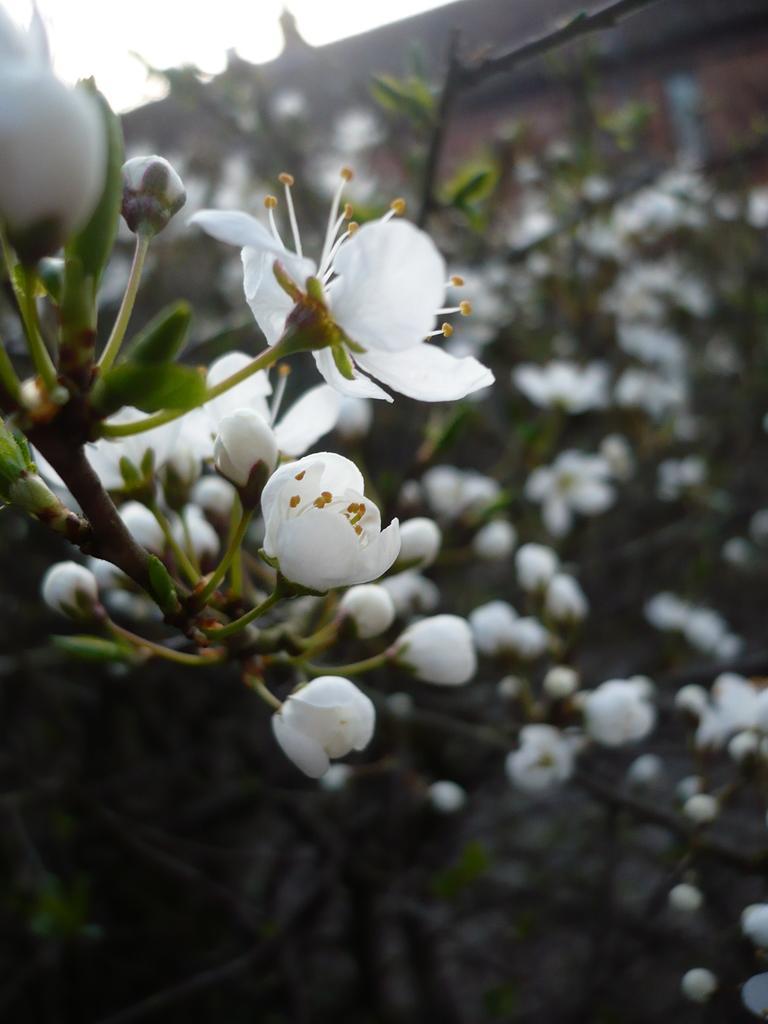Can you describe this image briefly? In this image I can see number of white colour flowers. I can also see this image is little bit blurry in the background. 